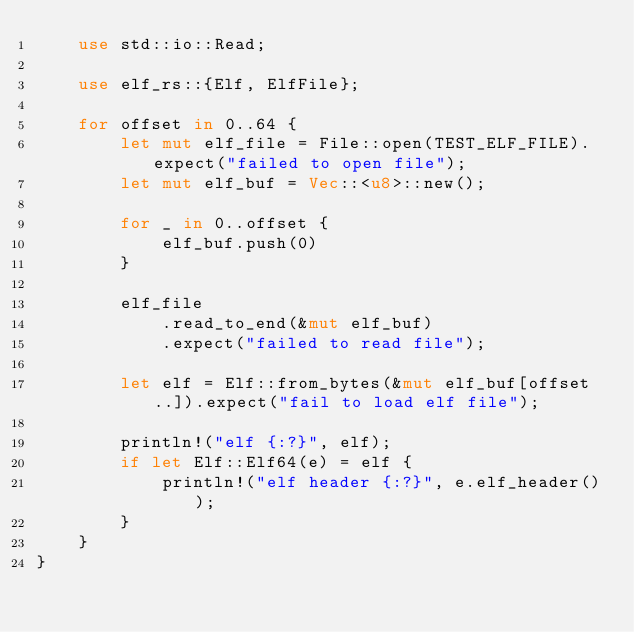Convert code to text. <code><loc_0><loc_0><loc_500><loc_500><_Rust_>    use std::io::Read;

    use elf_rs::{Elf, ElfFile};

    for offset in 0..64 {
        let mut elf_file = File::open(TEST_ELF_FILE).expect("failed to open file");
        let mut elf_buf = Vec::<u8>::new();

        for _ in 0..offset {
            elf_buf.push(0)
        }

        elf_file
            .read_to_end(&mut elf_buf)
            .expect("failed to read file");

        let elf = Elf::from_bytes(&mut elf_buf[offset..]).expect("fail to load elf file");

        println!("elf {:?}", elf);
        if let Elf::Elf64(e) = elf {
            println!("elf header {:?}", e.elf_header());
        }
    }
}
</code> 